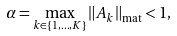<formula> <loc_0><loc_0><loc_500><loc_500>\alpha = \max _ { k \in \{ 1 , \dots , K \} } \| A _ { k } \| _ { \text {mat} } < 1 ,</formula> 